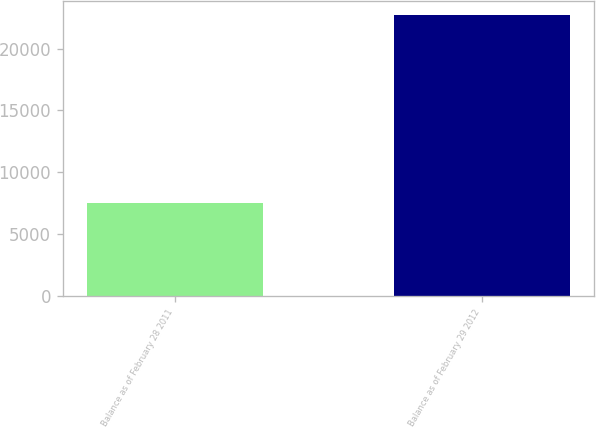<chart> <loc_0><loc_0><loc_500><loc_500><bar_chart><fcel>Balance as of February 28 2011<fcel>Balance as of February 29 2012<nl><fcel>7529<fcel>22685<nl></chart> 